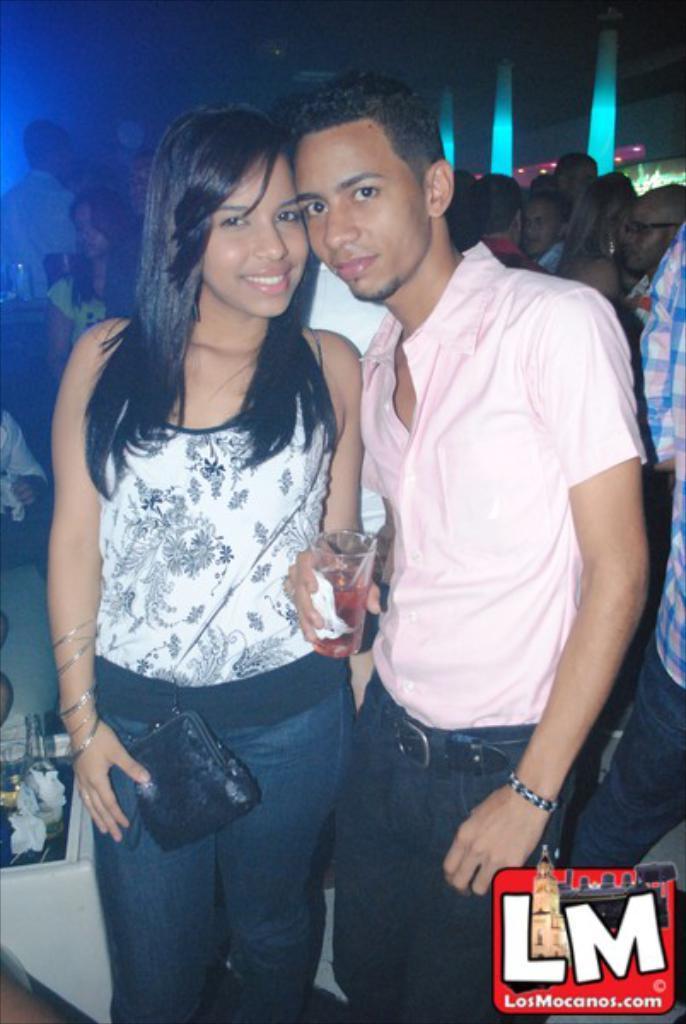In one or two sentences, can you explain what this image depicts? There is a woman holding a bag. Also there is a man holding a glass with tissue. In the background there are many people. Also there is a watermark in the right bottom corner. 